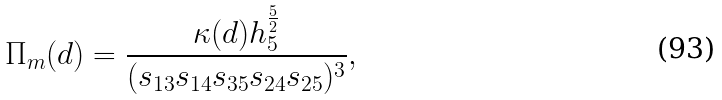<formula> <loc_0><loc_0><loc_500><loc_500>\Pi _ { m } ( d ) = \frac { \kappa ( d ) h _ { 5 } ^ { \frac { 5 } { 2 } } } { ( s _ { 1 3 } s _ { 1 4 } s _ { 3 5 } s _ { 2 4 } s _ { 2 5 } ) ^ { 3 } } ,</formula> 